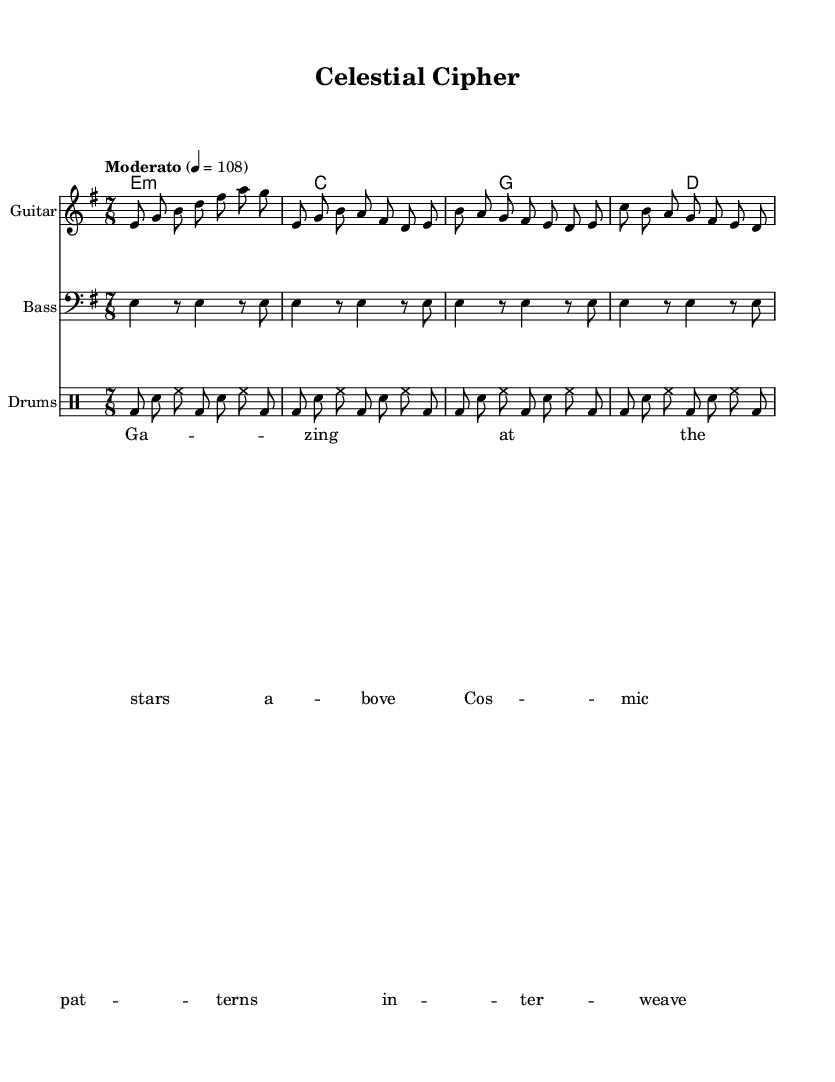What is the key signature of this music? The key signature is indicated in the global settings as E minor, which has one sharp (F sharp).
Answer: E minor What is the time signature of this piece? The time signature is shown in the global settings as 7/8, indicating seven eighth notes per measure.
Answer: 7/8 What is the tempo marking for the piece? The tempo is specified as "Moderato" with a metronome marking of quarter note = 108 beats per minute, which indicates a moderate speed.
Answer: Moderato How many measures are in the guitar part? The guitar part includes four distinct segments: an introduction, verse, chorus, and bridge, which constitutes a total of four measures. Each segment can be analyzed for its length; the intro has one measure, while the verse, chorus, and bridge have multiple measures in total.
Answer: Four What is the primary theme explored in the lyrics? The lyrics suggest cosmic themes with lines that reflect the beauty of stars and patterns in the universe, indicating a connection to astronomy and cosmic exploration.
Answer: Cosmic themes Which instrument plays the bass part? The bass part is explicitly indicated in the score with the instruction to use a bass clef, which is conventionally associated with the bass guitar.
Answer: Bass What chord follows the initial E minor chord in the chord progression? The chord progression outlines a sequence beginning with E minor, leading to C major as indicated in the chord naming section of the score.
Answer: C major 